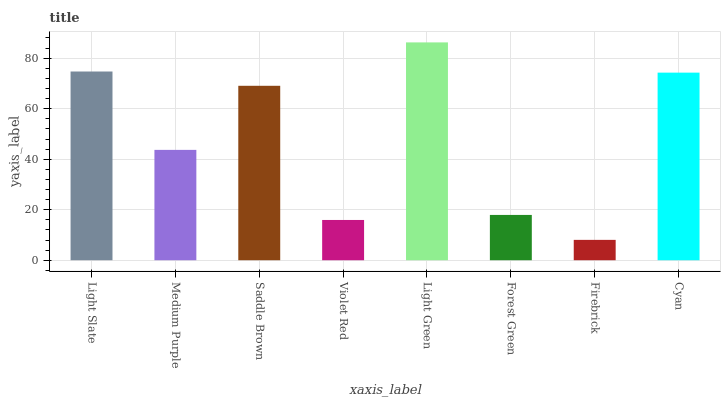Is Firebrick the minimum?
Answer yes or no. Yes. Is Light Green the maximum?
Answer yes or no. Yes. Is Medium Purple the minimum?
Answer yes or no. No. Is Medium Purple the maximum?
Answer yes or no. No. Is Light Slate greater than Medium Purple?
Answer yes or no. Yes. Is Medium Purple less than Light Slate?
Answer yes or no. Yes. Is Medium Purple greater than Light Slate?
Answer yes or no. No. Is Light Slate less than Medium Purple?
Answer yes or no. No. Is Saddle Brown the high median?
Answer yes or no. Yes. Is Medium Purple the low median?
Answer yes or no. Yes. Is Light Green the high median?
Answer yes or no. No. Is Light Slate the low median?
Answer yes or no. No. 